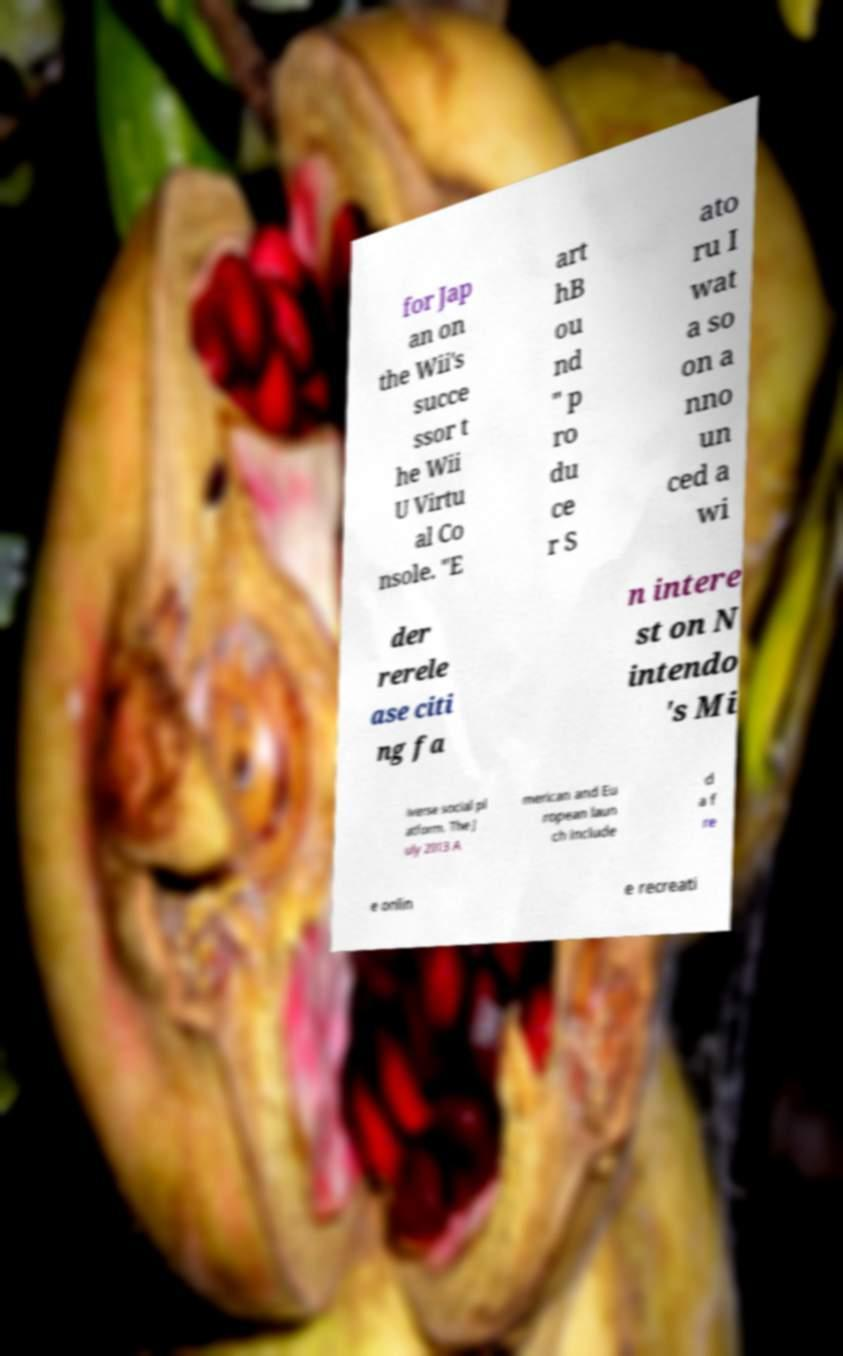Can you accurately transcribe the text from the provided image for me? for Jap an on the Wii's succe ssor t he Wii U Virtu al Co nsole. "E art hB ou nd " p ro du ce r S ato ru I wat a so on a nno un ced a wi der rerele ase citi ng fa n intere st on N intendo 's Mi iverse social pl atform. The J uly 2013 A merican and Eu ropean laun ch include d a f re e onlin e recreati 